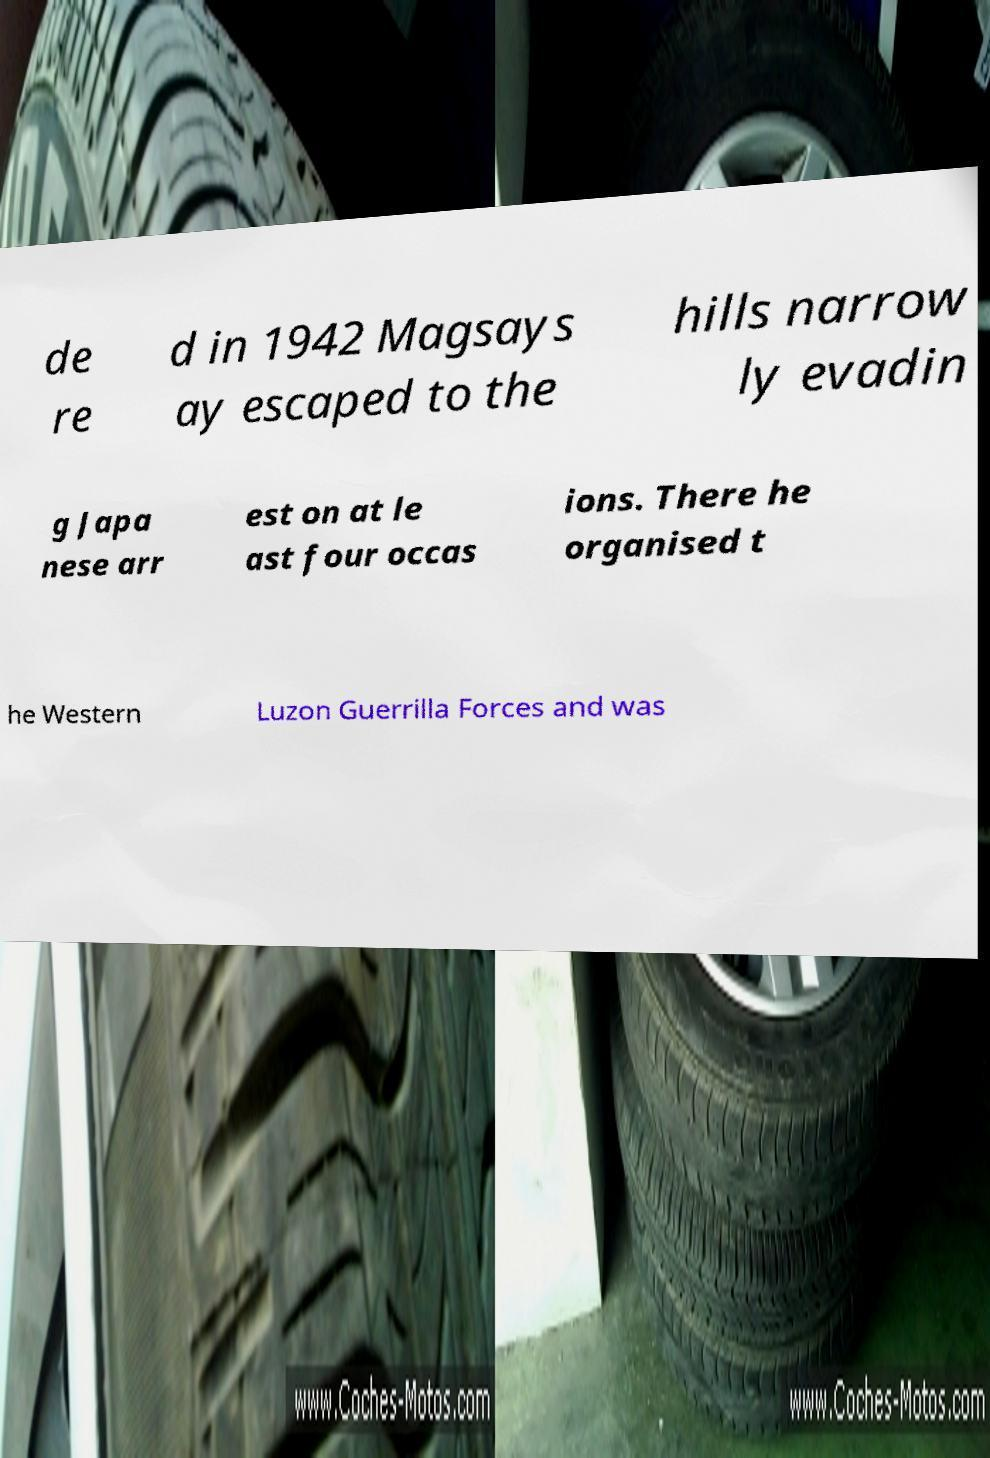For documentation purposes, I need the text within this image transcribed. Could you provide that? de re d in 1942 Magsays ay escaped to the hills narrow ly evadin g Japa nese arr est on at le ast four occas ions. There he organised t he Western Luzon Guerrilla Forces and was 